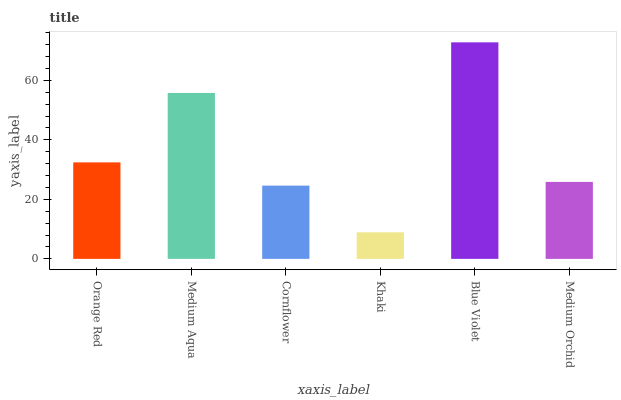Is Khaki the minimum?
Answer yes or no. Yes. Is Blue Violet the maximum?
Answer yes or no. Yes. Is Medium Aqua the minimum?
Answer yes or no. No. Is Medium Aqua the maximum?
Answer yes or no. No. Is Medium Aqua greater than Orange Red?
Answer yes or no. Yes. Is Orange Red less than Medium Aqua?
Answer yes or no. Yes. Is Orange Red greater than Medium Aqua?
Answer yes or no. No. Is Medium Aqua less than Orange Red?
Answer yes or no. No. Is Orange Red the high median?
Answer yes or no. Yes. Is Medium Orchid the low median?
Answer yes or no. Yes. Is Medium Orchid the high median?
Answer yes or no. No. Is Khaki the low median?
Answer yes or no. No. 